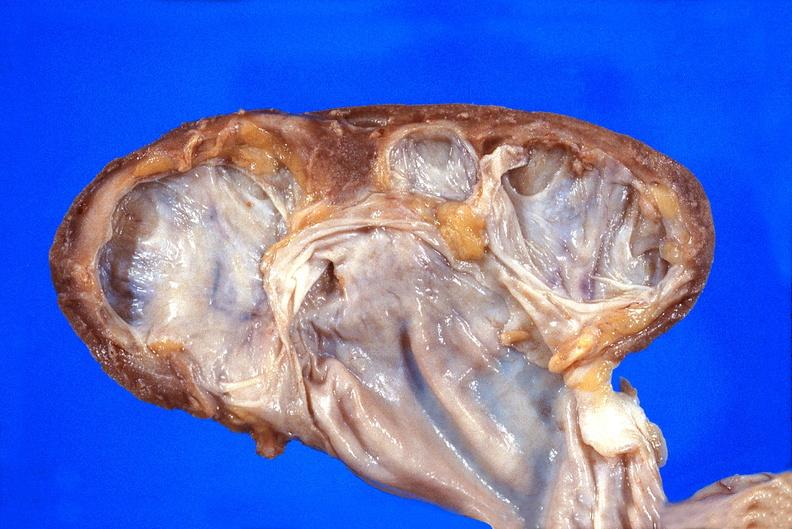does malignant histiocytosis show kidney, hydronephrosis?
Answer the question using a single word or phrase. No 